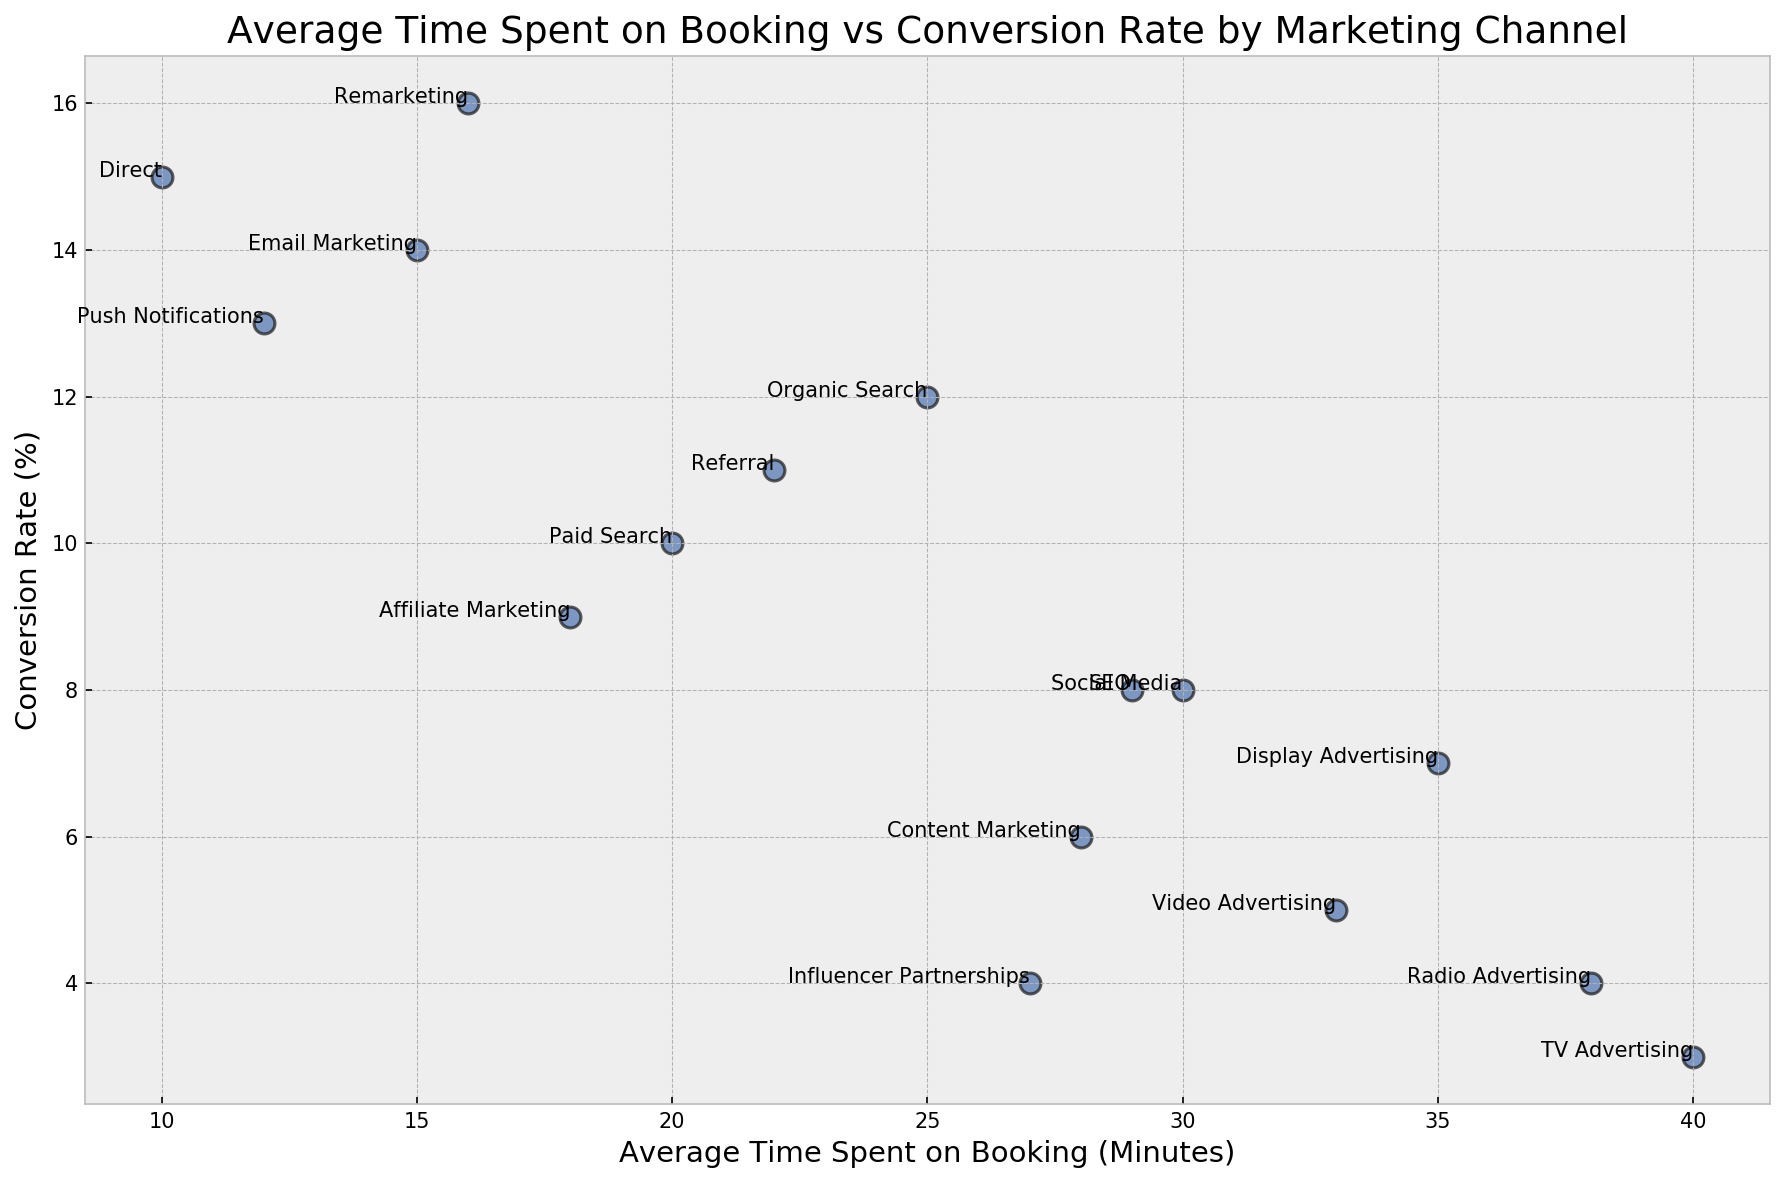What marketing channel has the highest conversion rate? By looking at the vertical axis labeled "Conversion Rate (%)" and finding the highest point, we see that "Remarketing" has the highest conversion rate.
Answer: Remarketing Which marketing channel has the shortest average time spent on booking? By checking the horizontal axis labeled "Average Time Spent on Booking (Minutes)" and finding the smallest value, we see that "Direct" has the shortest average time.
Answer: Direct Which channel has a higher conversion rate, Email Marketing or Social Media? Locate both "Email Marketing" and "Social Media" on the plot and compare their positions on the "Conversion Rate (%)" axis. "Email Marketing" is higher than "Social Media".
Answer: Email Marketing What's the difference in average time spent on booking between Direct and Display Advertising? Find "Direct" and "Display Advertising" on the horizontal axis and subtract the time of "Direct" (10 minutes) from "Display Advertising" (35 minutes). The difference is 35 - 10.
Answer: 25 minutes How many marketing channels have a conversion rate greater than 10%? Look for all the points above the 10% mark on the vertical axis and count them. The channels include Direct, Organic Search, Email Marketing, Push Notifications, and Remarketing.
Answer: 5 Which marketing channel has the lowest conversion rate and how much time on average is spent on booking for that channel? The lowest point on the conversion rate axis corresponds to "TV Advertising" with a conversion rate of 3%. The average time spent on booking for "TV Advertising" is 40 minutes.
Answer: TV Advertising and 40 minutes What is the median conversion rate for the listed marketing channels? Firstly, list all the conversion rates in ascending order: 3, 4, 4, 5, 6, 7, 8, 8, 9, 10, 11, 12, 13, 14, 15, 16. The median value in this list of 16 numbers is the average of the 8th and 9th values, which are both 8 and 9, so the median is (8+9)/2.
Answer: 8.5 Which two marketing channels have the same conversion rate and what is that rate? Observe the vertical axis and look for overlapping points. "Radio Advertising" and "Influencer Partnerships" both show a conversion rate of 4%.
Answer: Radio Advertising and Influencer Partnerships, 4% What marketing channel takes the longest average time for booking and how does its conversion rate compare to the average conversion rate of all channels? "TV Advertising" takes the longest time (40 minutes). To compare its rate (3%) with the average: sum all conversion rates (15+12+10+8+14+9+11+7+6+5+4+13+16+8+3+4=145), divide by 16 channels, average rate (145/16 = 9.06). "TV Advertising" with 3% is below the average.
Answer: TV Advertising, 3% is below average 9.06% 